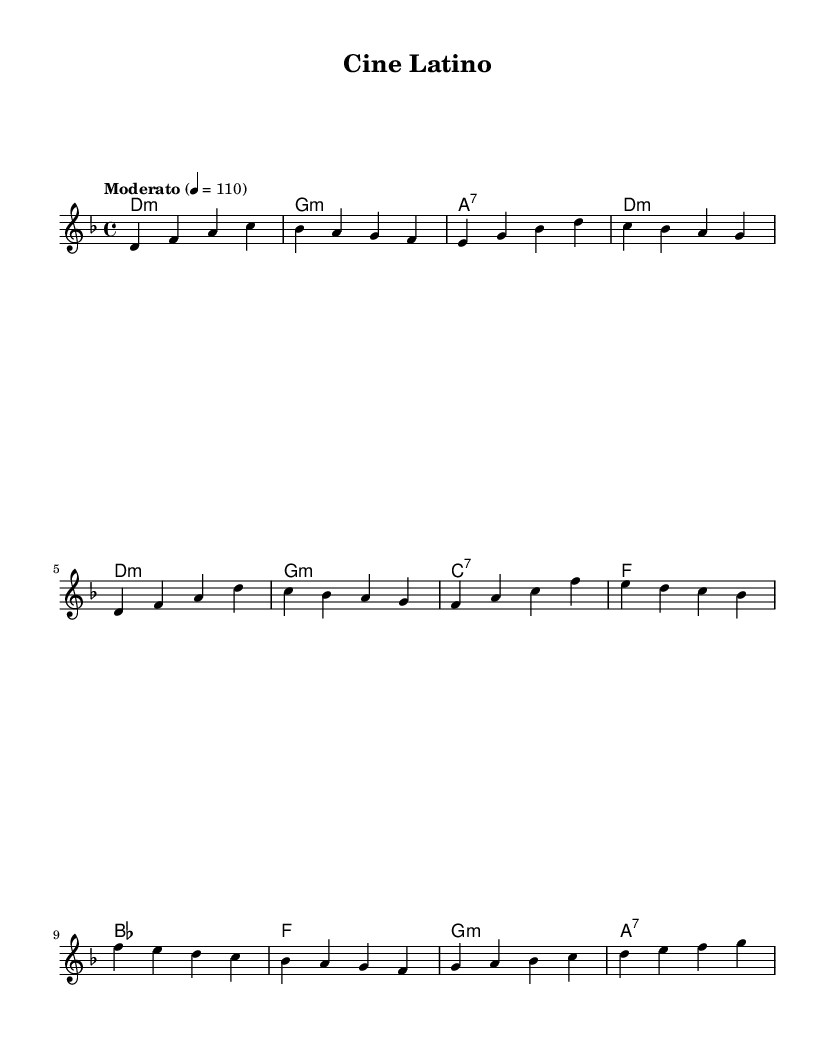What is the key signature of this music? The music is in D minor, which has one flat (B flat) in its key signature.
Answer: D minor What is the time signature of the piece? The time signature indicated in the score is 4/4, meaning there are four beats in each measure.
Answer: 4/4 What is the tempo marking of this music? The tempo marking specified is "Moderato," and it suggests a tempo of 110 beats per minute.
Answer: Moderato How many measures are in the chorus section? The chorus section consists of four measures; this can be counted by examining the bars in that section of the score.
Answer: 4 measures What is the relationship between the first chord of the intro and the key signature? The first chord is a D minor chord, which is the tonic chord of the D minor key signature, establishing the tonal center.
Answer: Tonic Which chord is used at the end of the chorus? The last chord in the chorus is A7, which typically functions as a dominant seventh chord leading back to D minor.
Answer: A7 Describe the overall structure of this piece. The piece has an intro, followed by a verse, and then a chorus, creating a clear form that is typical in songwriting.
Answer: Intro, Verse, Chorus 